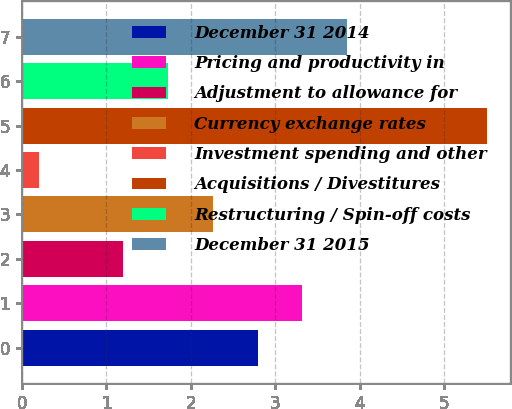Convert chart to OTSL. <chart><loc_0><loc_0><loc_500><loc_500><bar_chart><fcel>December 31 2014<fcel>Pricing and productivity in<fcel>Adjustment to allowance for<fcel>Currency exchange rates<fcel>Investment spending and other<fcel>Acquisitions / Divestitures<fcel>Restructuring / Spin-off costs<fcel>December 31 2015<nl><fcel>2.79<fcel>3.32<fcel>1.2<fcel>2.26<fcel>0.2<fcel>5.5<fcel>1.73<fcel>3.85<nl></chart> 